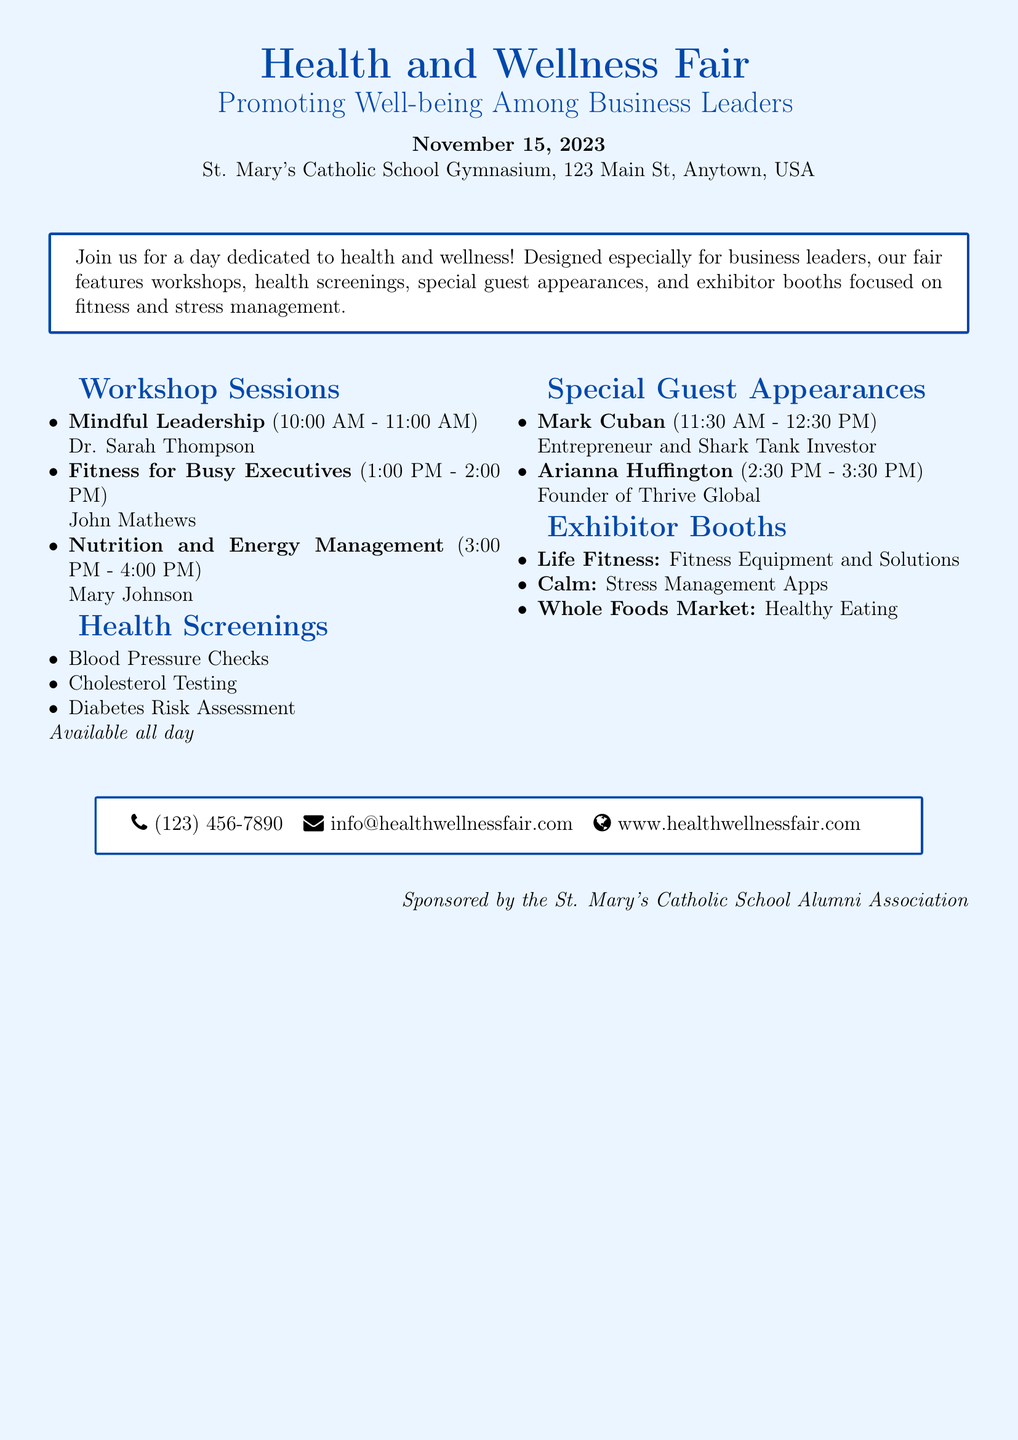What is the date of the Health and Wellness Fair? The date is explicitly mentioned in the document as November 15, 2023.
Answer: November 15, 2023 Where is the event being held? The location is stated in the document as St. Mary's Catholic School Gymnasium, 123 Main St, Anytown, USA.
Answer: St. Mary's Catholic School Gymnasium Who is presenting the "Mindful Leadership" workshop? The document lists Dr. Sarah Thompson as the presenter for that specific workshop.
Answer: Dr. Sarah Thompson What type of assessments are available all day? The document lists Blood Pressure Checks, Cholesterol Testing, and Diabetes Risk Assessment as available assessments.
Answer: Blood Pressure Checks Who is one of the special guests attending the event? Mark Cuban is mentioned as a special guest appearing from 11:30 AM to 12:30 PM.
Answer: Mark Cuban What is the focus of the exhibitor booths? The exhibitor booths focus on fitness and stress management as indicated in the introduction of the document.
Answer: Fitness and stress management What time is the "Nutrition and Energy Management" workshop scheduled? The specific time for this workshop is given in the document as 3:00 PM - 4:00 PM.
Answer: 3:00 PM - 4:00 PM Which organization sponsors the event? The document clearly states that the event is sponsored by the St. Mary's Catholic School Alumni Association.
Answer: St. Mary's Catholic School Alumni Association 